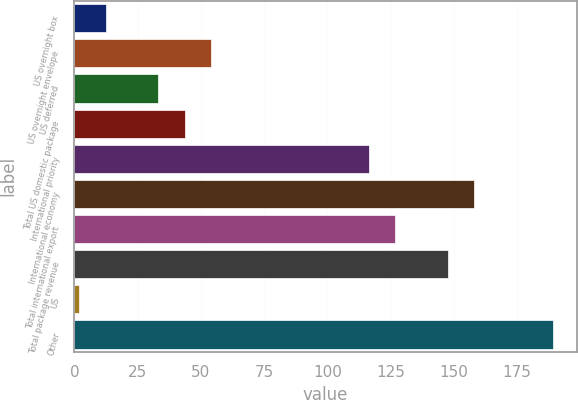<chart> <loc_0><loc_0><loc_500><loc_500><bar_chart><fcel>US overnight box<fcel>US overnight envelope<fcel>US deferred<fcel>Total US domestic package<fcel>International priority<fcel>International economy<fcel>Total international export<fcel>Total package revenue<fcel>US<fcel>Other<nl><fcel>12.4<fcel>54<fcel>33.2<fcel>43.6<fcel>116.4<fcel>158<fcel>126.8<fcel>147.6<fcel>2<fcel>189.2<nl></chart> 